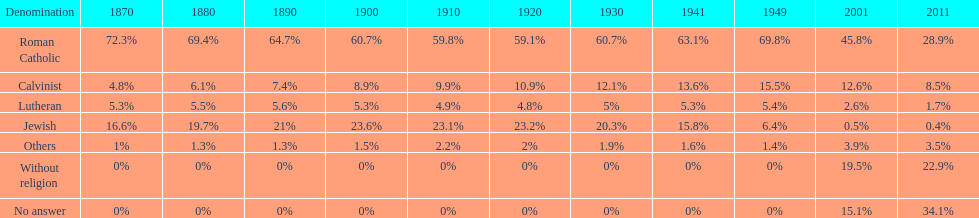Write the full table. {'header': ['Denomination', '1870', '1880', '1890', '1900', '1910', '1920', '1930', '1941', '1949', '2001', '2011'], 'rows': [['Roman Catholic', '72.3%', '69.4%', '64.7%', '60.7%', '59.8%', '59.1%', '60.7%', '63.1%', '69.8%', '45.8%', '28.9%'], ['Calvinist', '4.8%', '6.1%', '7.4%', '8.9%', '9.9%', '10.9%', '12.1%', '13.6%', '15.5%', '12.6%', '8.5%'], ['Lutheran', '5.3%', '5.5%', '5.6%', '5.3%', '4.9%', '4.8%', '5%', '5.3%', '5.4%', '2.6%', '1.7%'], ['Jewish', '16.6%', '19.7%', '21%', '23.6%', '23.1%', '23.2%', '20.3%', '15.8%', '6.4%', '0.5%', '0.4%'], ['Others', '1%', '1.3%', '1.3%', '1.5%', '2.2%', '2%', '1.9%', '1.6%', '1.4%', '3.9%', '3.5%'], ['Without religion', '0%', '0%', '0%', '0%', '0%', '0%', '0%', '0%', '0%', '19.5%', '22.9%'], ['No answer', '0%', '0%', '0%', '0%', '0%', '0%', '0%', '0%', '0%', '15.1%', '34.1%']]} Which religious group had the highest proportion in 1880? Roman Catholic. 